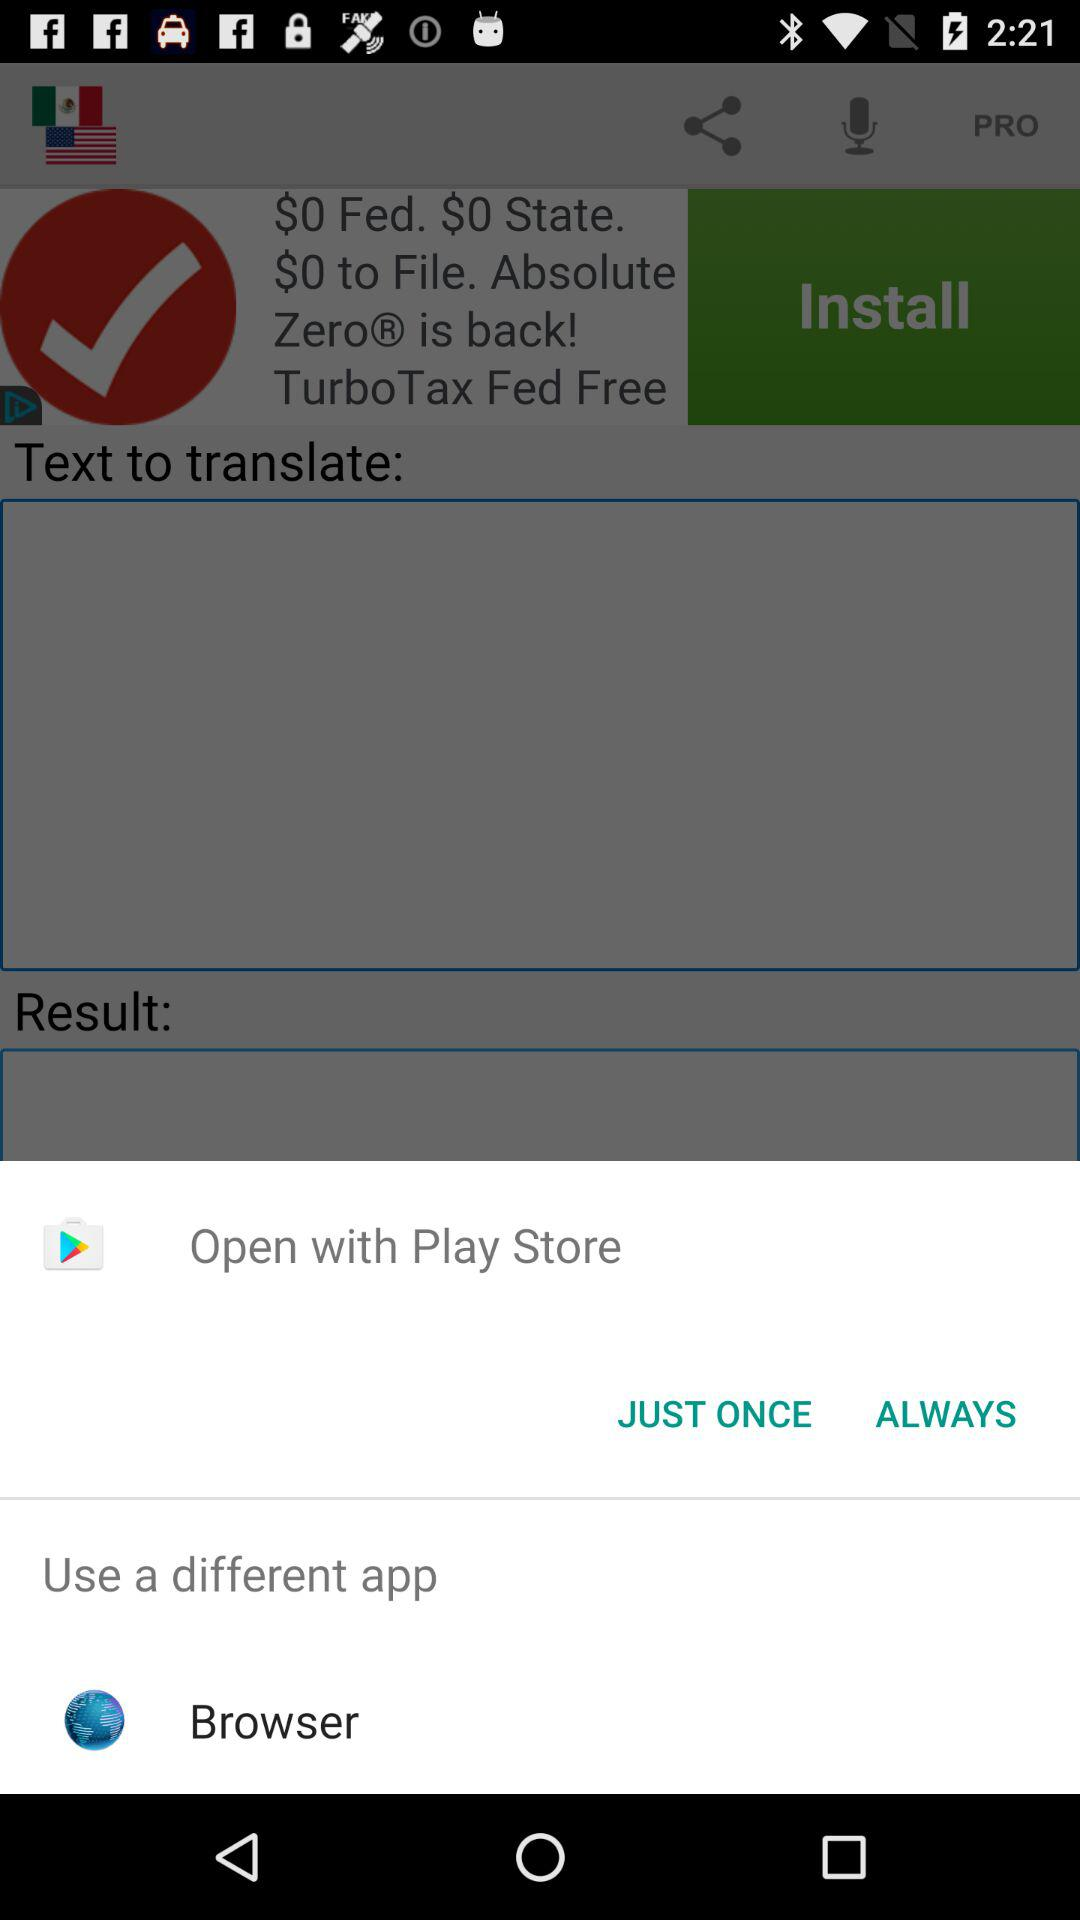With which application can we open? You can open with "Play Store" and "Browser". 